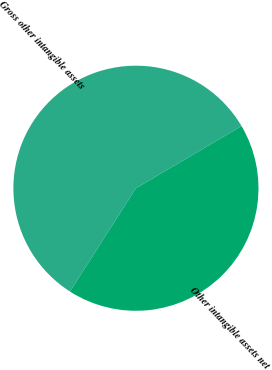Convert chart to OTSL. <chart><loc_0><loc_0><loc_500><loc_500><pie_chart><fcel>Gross other intangible assets<fcel>Other intangible assets net<nl><fcel>57.49%<fcel>42.51%<nl></chart> 